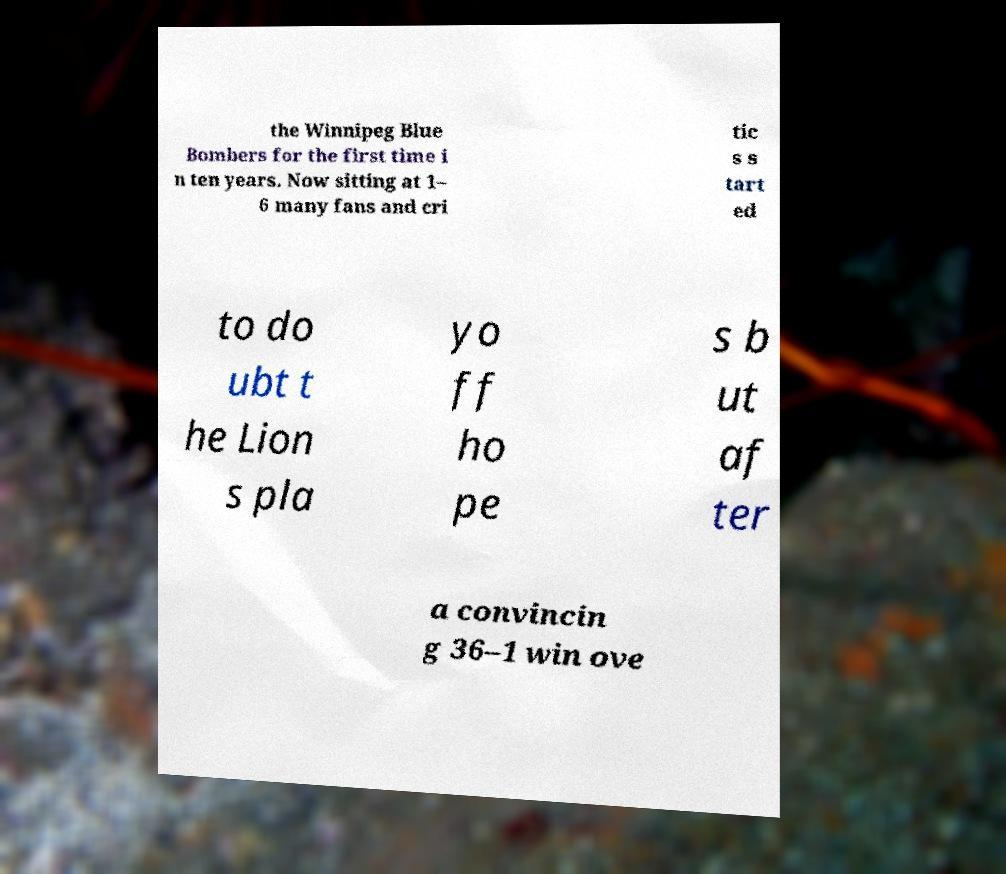I need the written content from this picture converted into text. Can you do that? the Winnipeg Blue Bombers for the first time i n ten years. Now sitting at 1– 6 many fans and cri tic s s tart ed to do ubt t he Lion s pla yo ff ho pe s b ut af ter a convincin g 36–1 win ove 